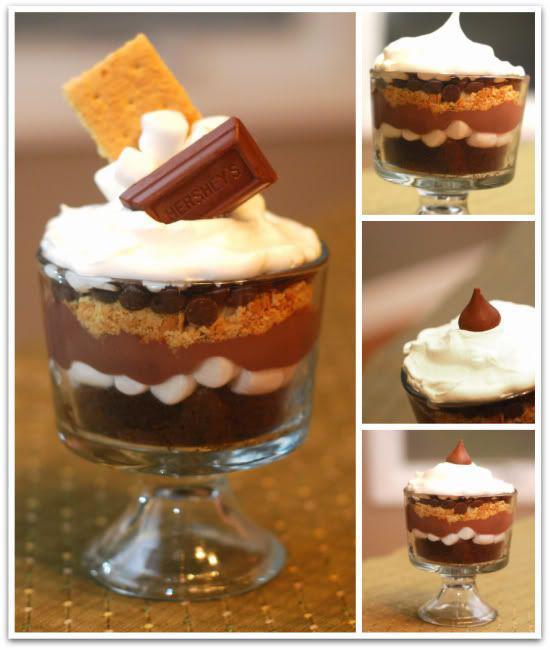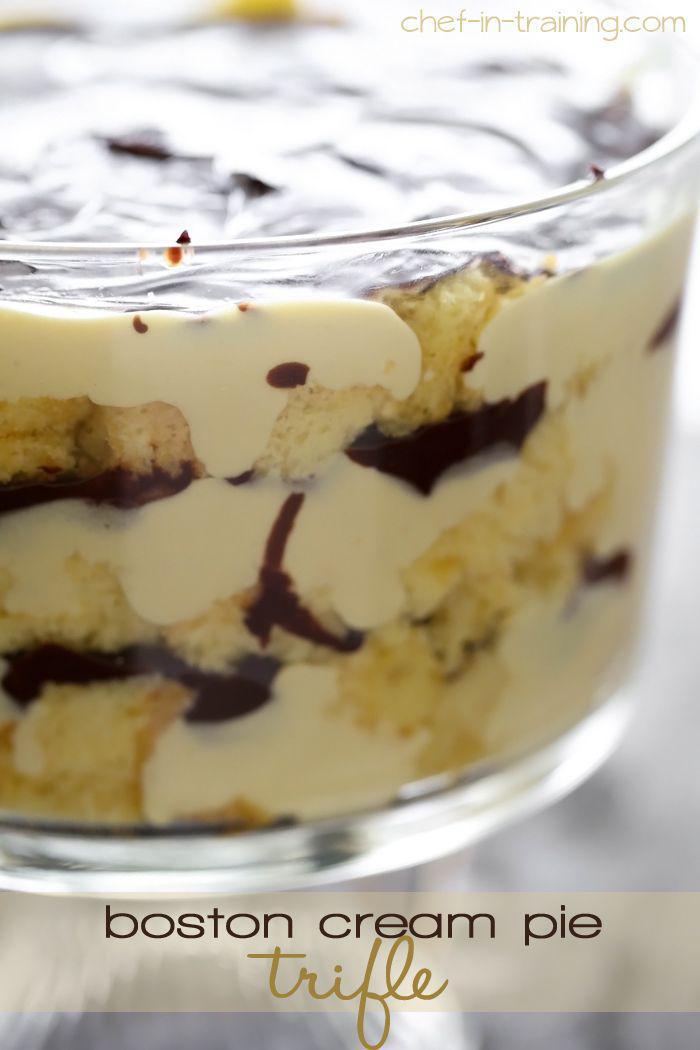The first image is the image on the left, the second image is the image on the right. For the images shown, is this caption "Two large multi-layered desserts have been prepared in clear glass footed bowls" true? Answer yes or no. No. The first image is the image on the left, the second image is the image on the right. Examine the images to the left and right. Is the description "An image of a layered dessert in a clear glass includes lemon in the scene." accurate? Answer yes or no. No. 